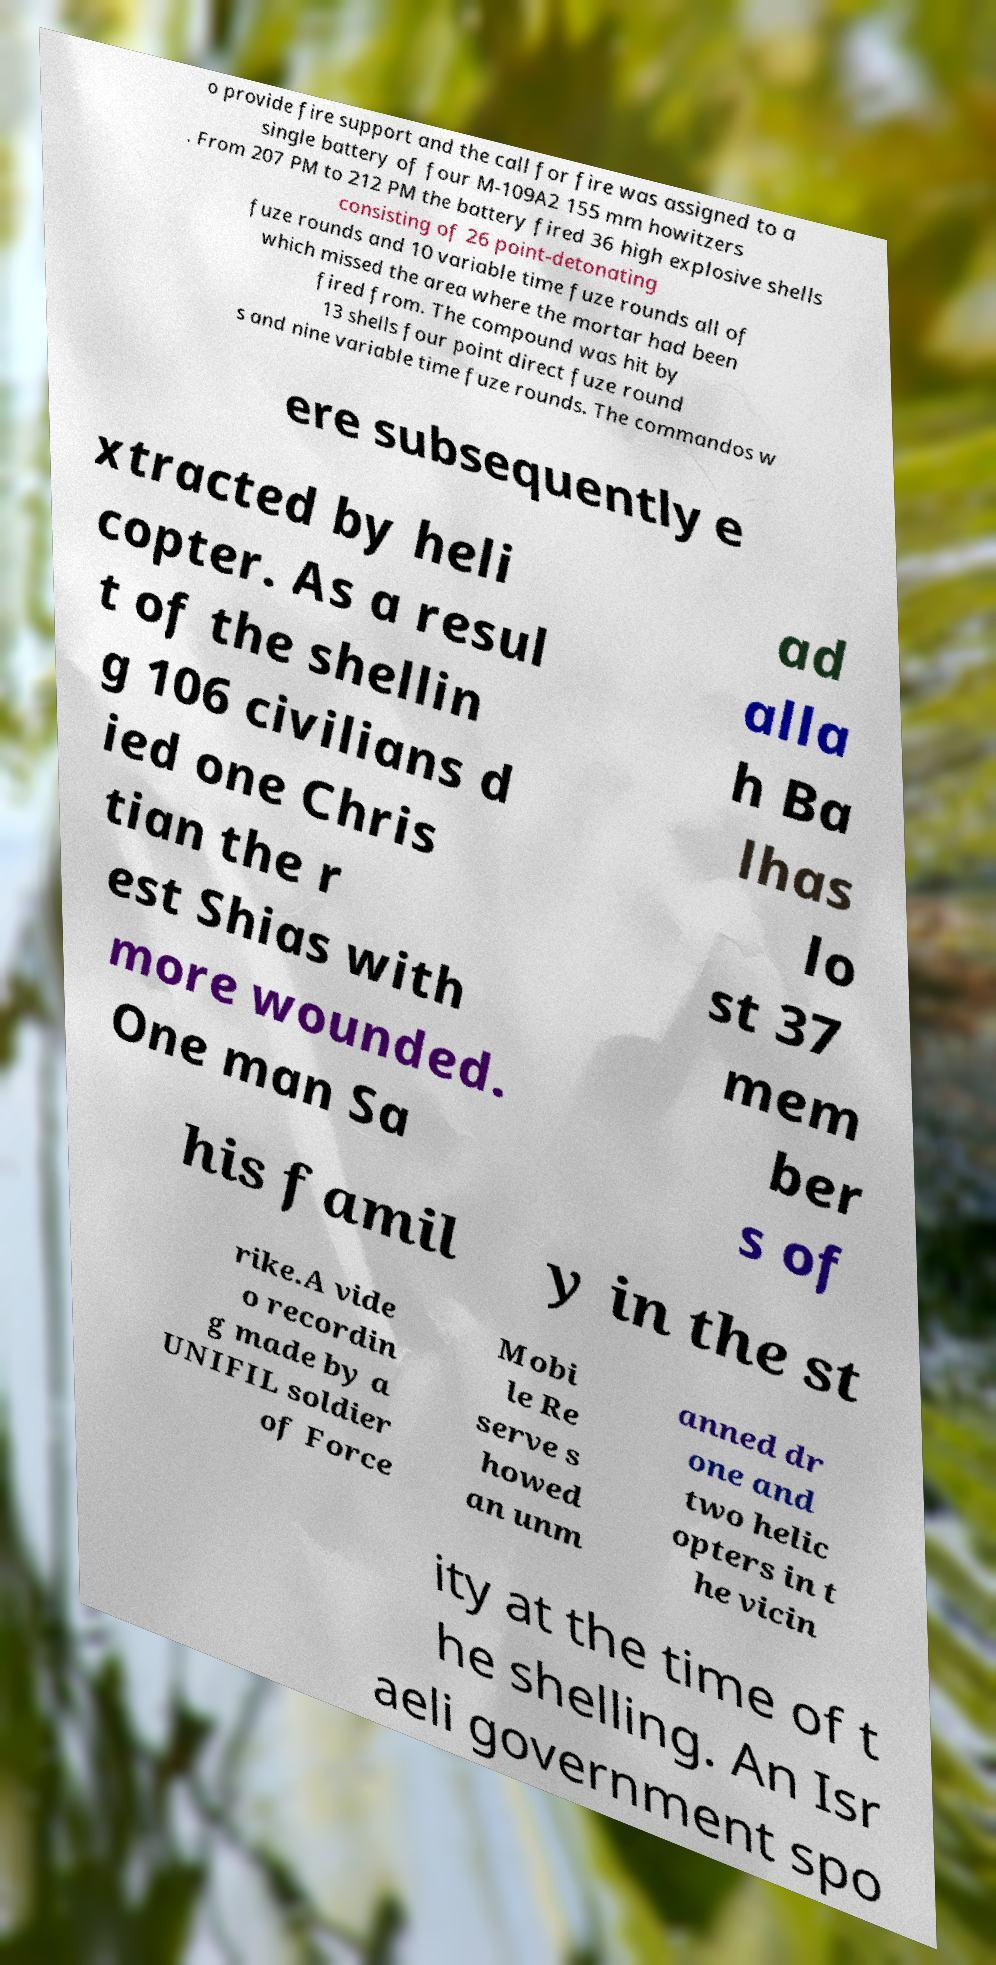For documentation purposes, I need the text within this image transcribed. Could you provide that? o provide fire support and the call for fire was assigned to a single battery of four M-109A2 155 mm howitzers . From 207 PM to 212 PM the battery fired 36 high explosive shells consisting of 26 point-detonating fuze rounds and 10 variable time fuze rounds all of which missed the area where the mortar had been fired from. The compound was hit by 13 shells four point direct fuze round s and nine variable time fuze rounds. The commandos w ere subsequently e xtracted by heli copter. As a resul t of the shellin g 106 civilians d ied one Chris tian the r est Shias with more wounded. One man Sa ad alla h Ba lhas lo st 37 mem ber s of his famil y in the st rike.A vide o recordin g made by a UNIFIL soldier of Force Mobi le Re serve s howed an unm anned dr one and two helic opters in t he vicin ity at the time of t he shelling. An Isr aeli government spo 